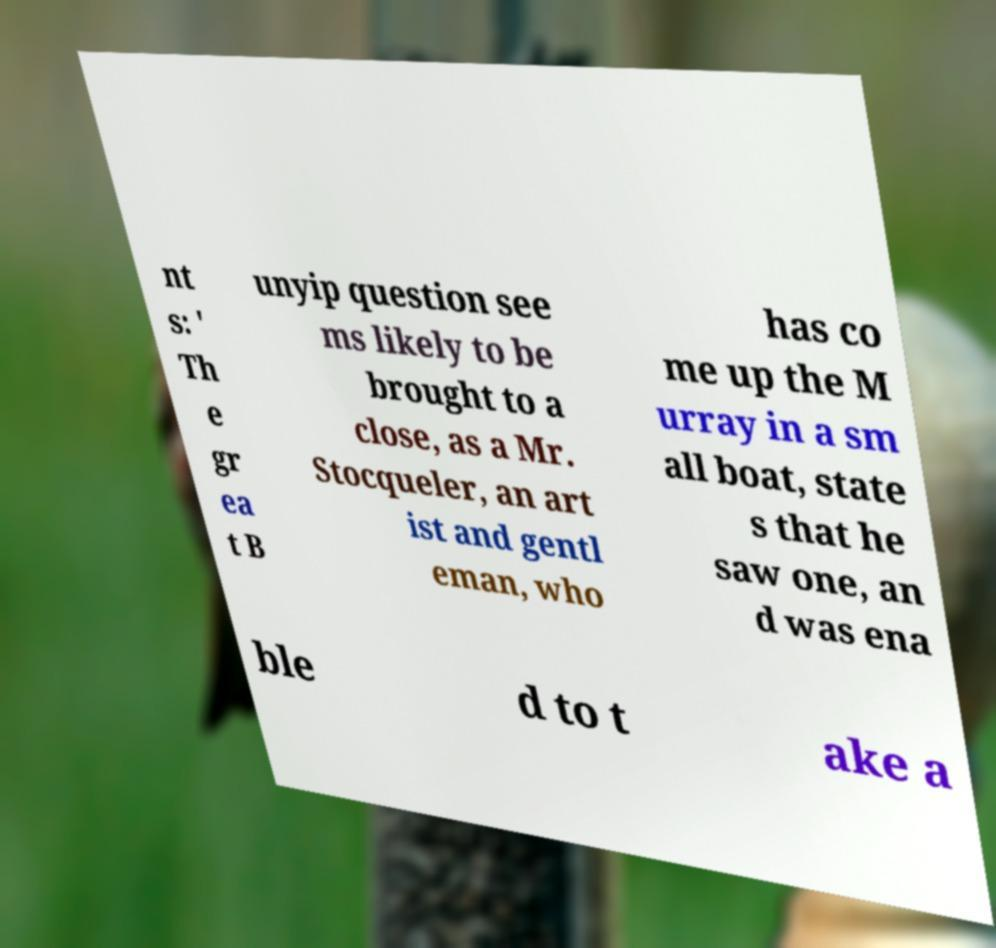Can you read and provide the text displayed in the image?This photo seems to have some interesting text. Can you extract and type it out for me? nt s: ' Th e gr ea t B unyip question see ms likely to be brought to a close, as a Mr. Stocqueler, an art ist and gentl eman, who has co me up the M urray in a sm all boat, state s that he saw one, an d was ena ble d to t ake a 